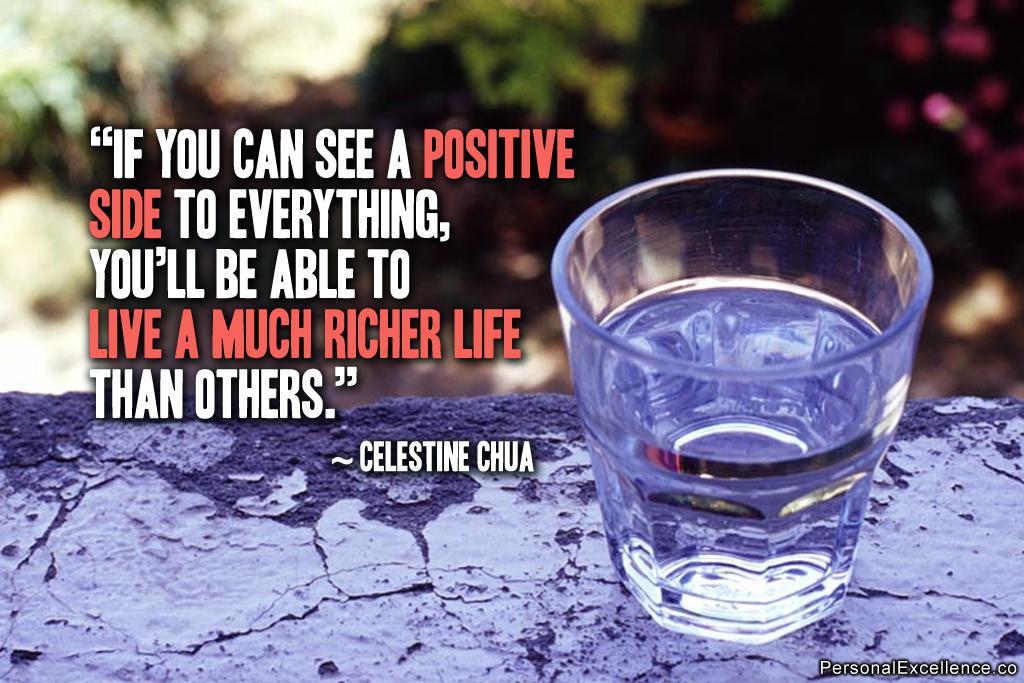Who said this quote?
Your response must be concise. Celestine chua. Is this about being positive?
Provide a succinct answer. Yes. 